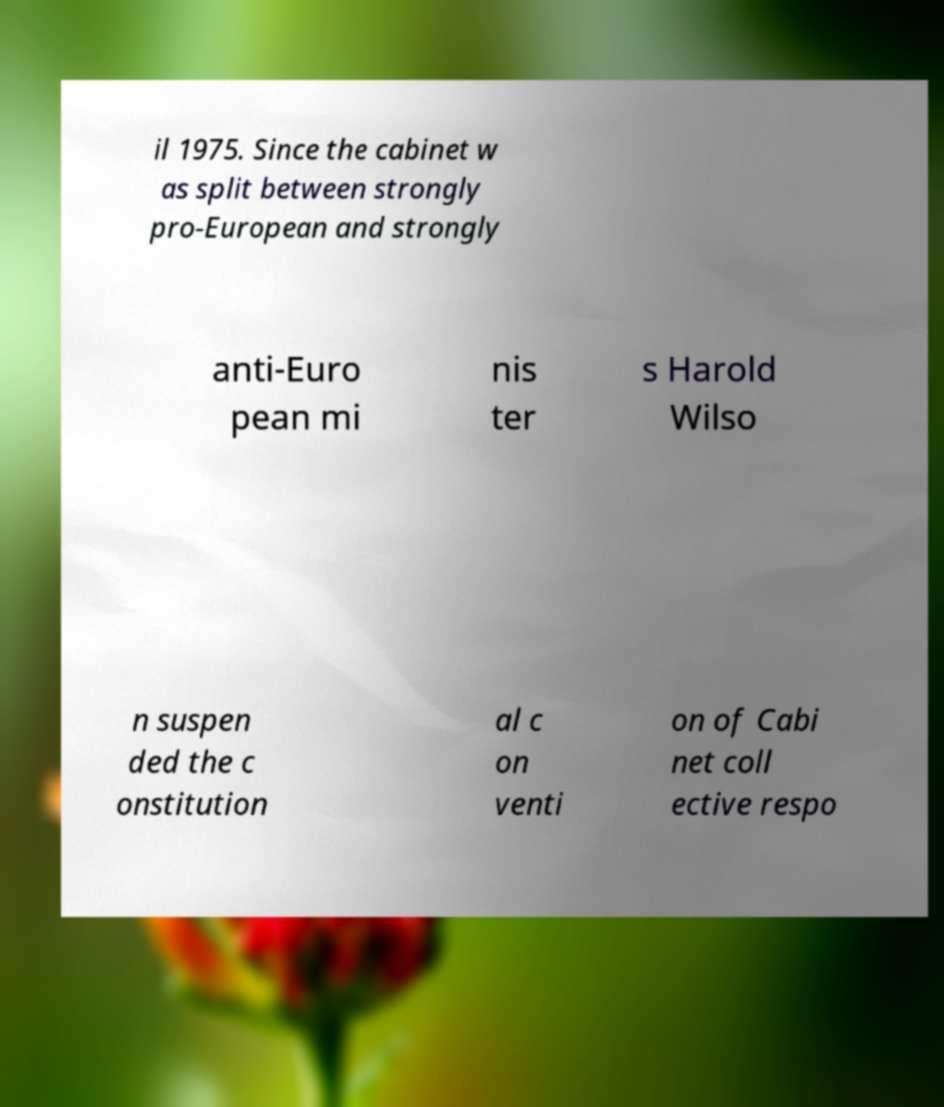There's text embedded in this image that I need extracted. Can you transcribe it verbatim? il 1975. Since the cabinet w as split between strongly pro-European and strongly anti-Euro pean mi nis ter s Harold Wilso n suspen ded the c onstitution al c on venti on of Cabi net coll ective respo 